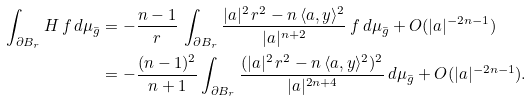Convert formula to latex. <formula><loc_0><loc_0><loc_500><loc_500>\int _ { \partial B _ { r } } H \, f \, d \mu _ { \bar { g } } & = - \frac { n - 1 } { r } \, \int _ { \partial B _ { r } } \frac { | a | ^ { 2 } \, r ^ { 2 } - n \, \langle a , y \rangle ^ { 2 } } { | a | ^ { n + 2 } } \, f \, d \mu _ { \bar { g } } + O ( | a | ^ { - 2 n - 1 } ) \\ & = - \frac { ( n - 1 ) ^ { 2 } } { n + 1 } \int _ { \partial B _ { r } } \frac { ( | a | ^ { 2 } \, r ^ { 2 } - n \, \langle a , y \rangle ^ { 2 } ) ^ { 2 } } { | a | ^ { 2 n + 4 } } \, d \mu _ { \bar { g } } + O ( | a | ^ { - 2 n - 1 } ) .</formula> 